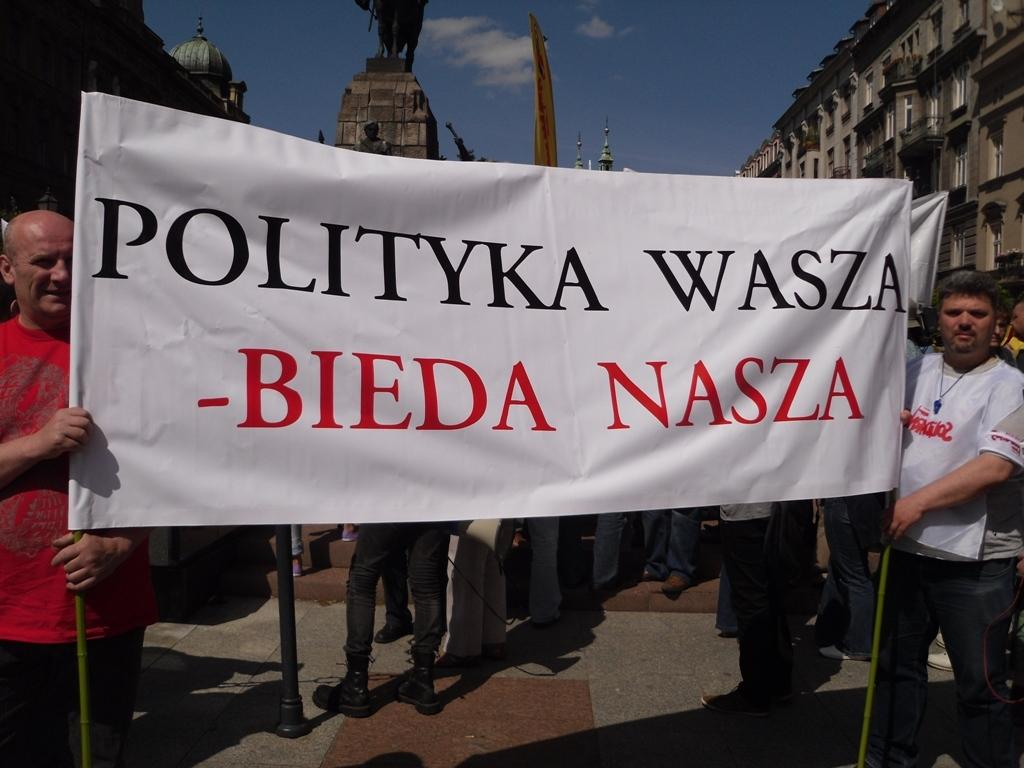Where was the image taken? The image was clicked outside. What are the people in the middle of the image doing? The people are holding banners in the middle of the image. What can be seen on both sides of the image? There are buildings on the right side and the left side of the image. What is visible at the top of the image? The sky is visible at the top of the image. Can you tell me how many hydrants are visible in the image? There are no hydrants present in the image. What type of partner is standing next to the person holding the banner? There is no partner visible in the image, as it only shows people holding banners and buildings in the background. 